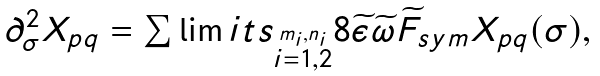<formula> <loc_0><loc_0><loc_500><loc_500>\begin{array} { l c r } \partial _ { \sigma } ^ { 2 } X _ { p q } = \sum \lim i t s _ { \stackrel { m _ { i } , n _ { i } } { i = 1 , 2 } } 8 \widetilde { \epsilon } \widetilde { \omega } \widetilde { F } _ { s y m } X _ { p q } ( \sigma ) , \end{array}</formula> 